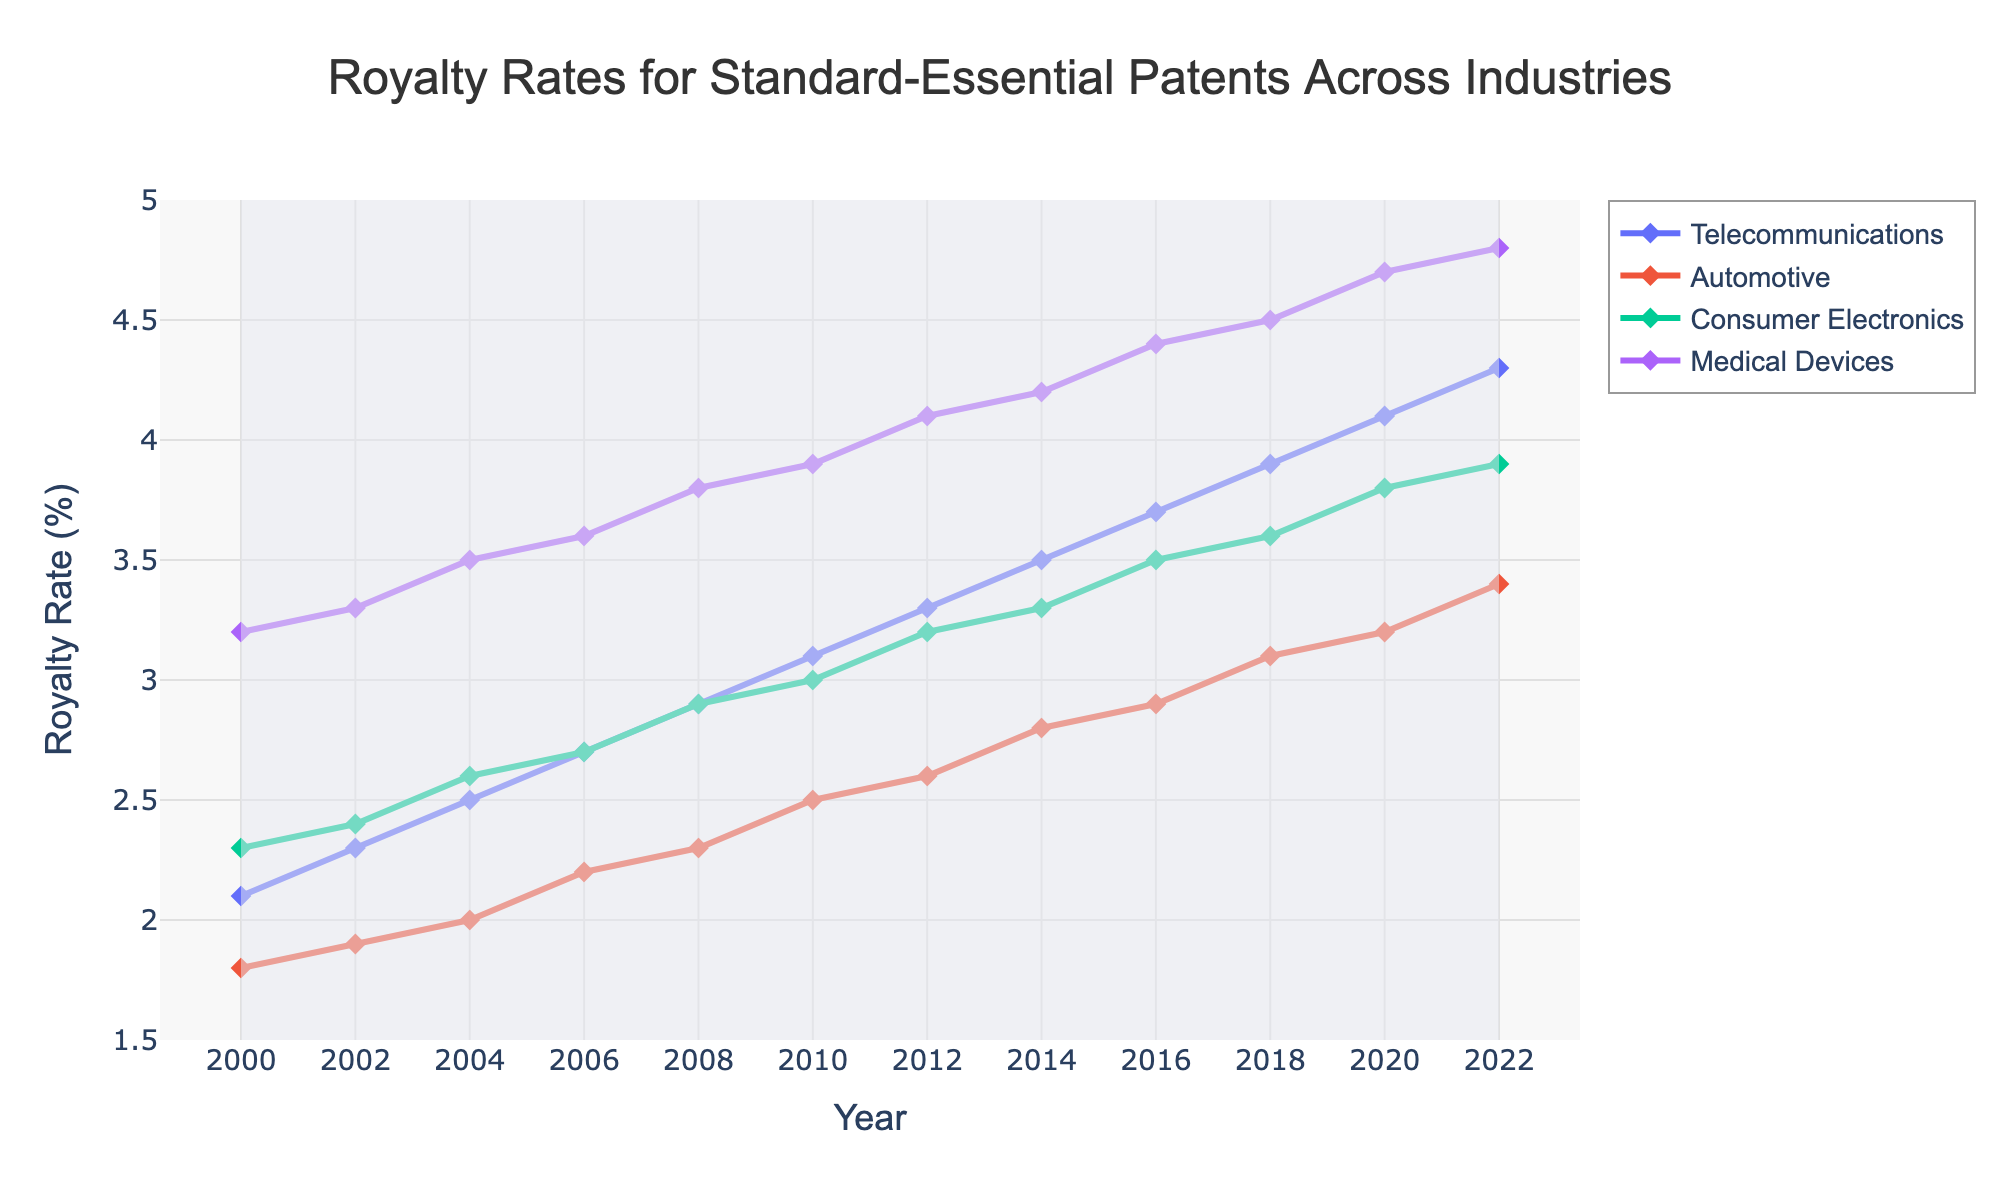What is the trend in royalty rates for telecommunications from 2000 to 2022? To determine the trend in telecommunications royalty rates from 2000 to 2022, observe the line associated with telecommunications. The line shows a steady increase from 2.1% in 2000 to 4.3% in 2022.
Answer: Increasing What was the difference in royalty rates between medical devices and consumer electronics in 2018? The royalty rate for medical devices in 2018 is 4.5%, and for consumer electronics, it is 3.6%. The difference is calculated by subtracting 3.6 from 4.5.
Answer: 0.9% Which industry had the highest royalty rate in the year 2000? To find the industry with the highest royalty rate in 2000, compare the values for all four industries. Medical devices have the highest rate at 3.2%.
Answer: Medical Devices What is the average royalty rate for automotive patents from 2008 to 2020? The royalty rates for automotive from 2008 to 2020 are 2.3, 2.5, 2.6, 2.8, 2.9, and 3.1. Sum these up and divide by 6: (2.3 + 2.5 + 2.6 + 2.8 + 2.9 + 3.1) / 6 = 16.2 / 6.
Answer: 2.7% In which year did automotive patents see their largest increase in royalty rate? Examine the yearly increases for automotive patents. The largest increase is between 2010 and 2012, where the royalty rate increased from 2.5% to 2.6%.
Answer: 2010-2012 How did the royalty rate trend for consumer electronics compare to that of medical devices from 2000 to 2022? To compare the trends, observe the lines for consumer electronics and medical devices. Both show an increasing trend. Consumer electronics rise from 2.3% to 3.9%, while medical devices increase from 3.2% to 4.8%.
Answer: Both increased What is the overall average royalty rate for telecommunications from 2000 to 2022? Sum the royalty rates for telecommunications from 2000 to 2022: 2.1, 2.3, 2.5, 2.7, 2.9, 3.1, 3.3, 3.5, 3.7, 3.9, 4.1, 4.3. The total is 38.4. Divide this by 12 (the number of years).
Answer: 3.2% Which industry has the steepest increase in royalty rates between any two consecutive data points? Calculate the differences between consecutive data points for each industry. Consumer electronics have a rise from 2.9 to 3.0 between 2008 and 2010. Medical devices have a rise from 3.8 to 3.9 in the same period. The actual largest increase is for automotive from 2.9% in 2018 to 3.2% in 2020.
Answer: Automotive (2018-2020) What is the median royalty rate for medical devices from the data provided? List the rates for medical devices: 3.2, 3.3, 3.5, 3.6, 3.8, 3.9, 4.1, 4.2, 4.4, 4.5, 4.7, 4.8. As there are 12 data points, the median will be the average of the 6th and 7th values: (3.9 + 4.1)/2.
Answer: 4.0% What is the increase in the royalty rate for consumer electronics from 2010 to 2022? The rate in 2010 is 3.0%, and in 2022 it is 3.9%. The increase is found by subtracting 3.0 from 3.9.
Answer: 0.9% 